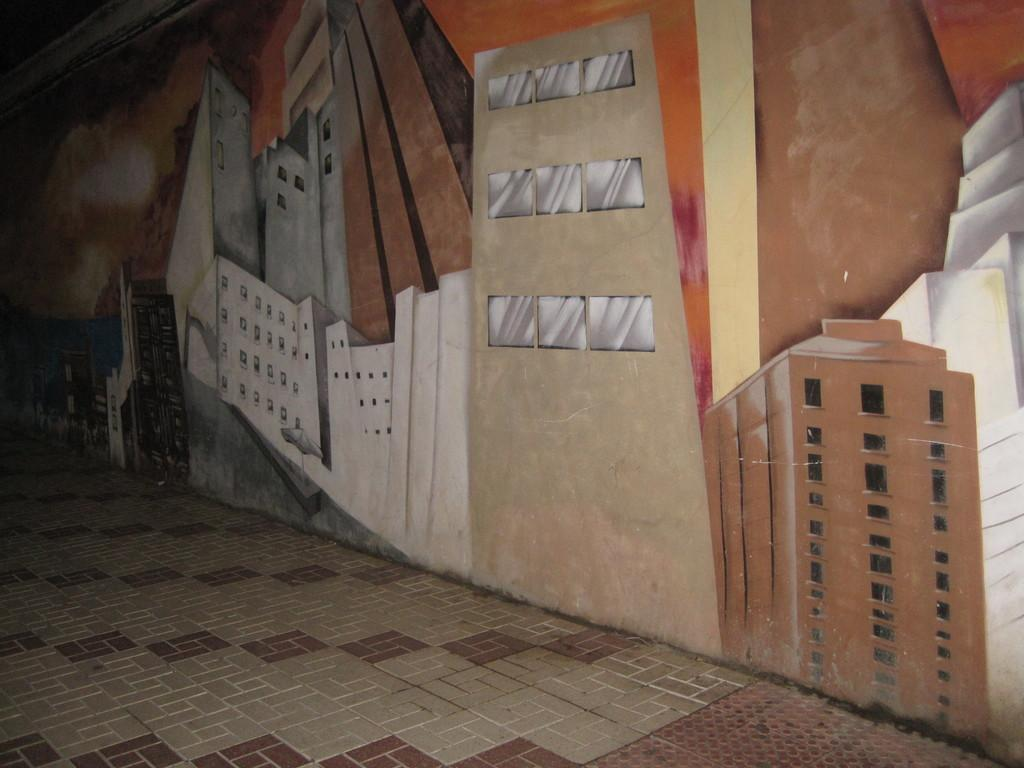Where was the image taken? The image was taken indoors. What can be seen in the middle of the image? There is a wall with paintings in the middle of the image. What is visible at the bottom of the image? There is a floor visible at the bottom of the image. What time does the carpenter arrive in the image? There is no carpenter present in the image, so it is not possible to determine when they might arrive. 